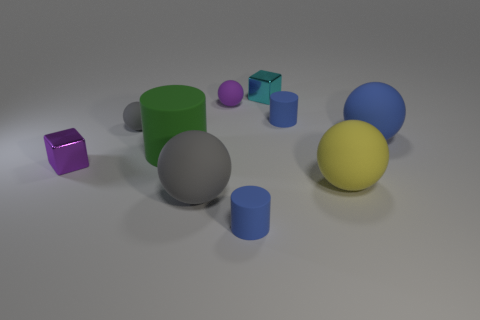There is a blue matte thing that is the same shape as the yellow thing; what size is it?
Your answer should be compact. Large. What number of small objects have the same material as the small cyan cube?
Give a very brief answer. 1. Is the material of the gray object in front of the yellow ball the same as the small purple sphere?
Provide a succinct answer. Yes. Is the number of cyan cubes that are in front of the large yellow object the same as the number of tiny red cubes?
Provide a succinct answer. Yes. The green thing is what size?
Your response must be concise. Large. How many spheres are the same color as the big cylinder?
Your answer should be compact. 0. Do the purple rubber sphere and the cyan thing have the same size?
Provide a succinct answer. Yes. There is a gray thing behind the small metallic object in front of the purple rubber thing; how big is it?
Give a very brief answer. Small. Are there any blue balls of the same size as the yellow thing?
Provide a short and direct response. Yes. What is the size of the gray ball that is behind the blue sphere?
Ensure brevity in your answer.  Small. 